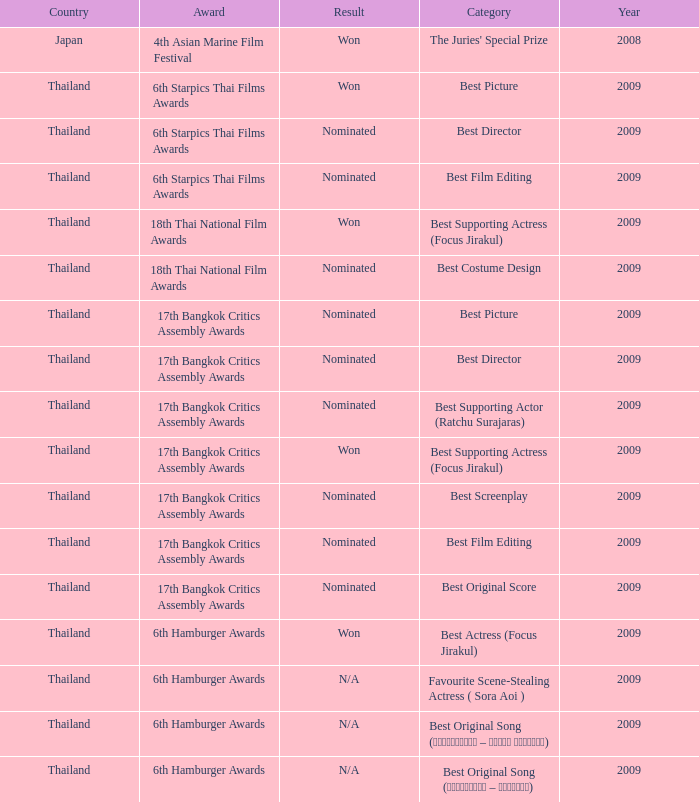Which Year has a Category of best original song (รอเธอหันมา – โฟกัส จิระกุล)? 2009.0. 